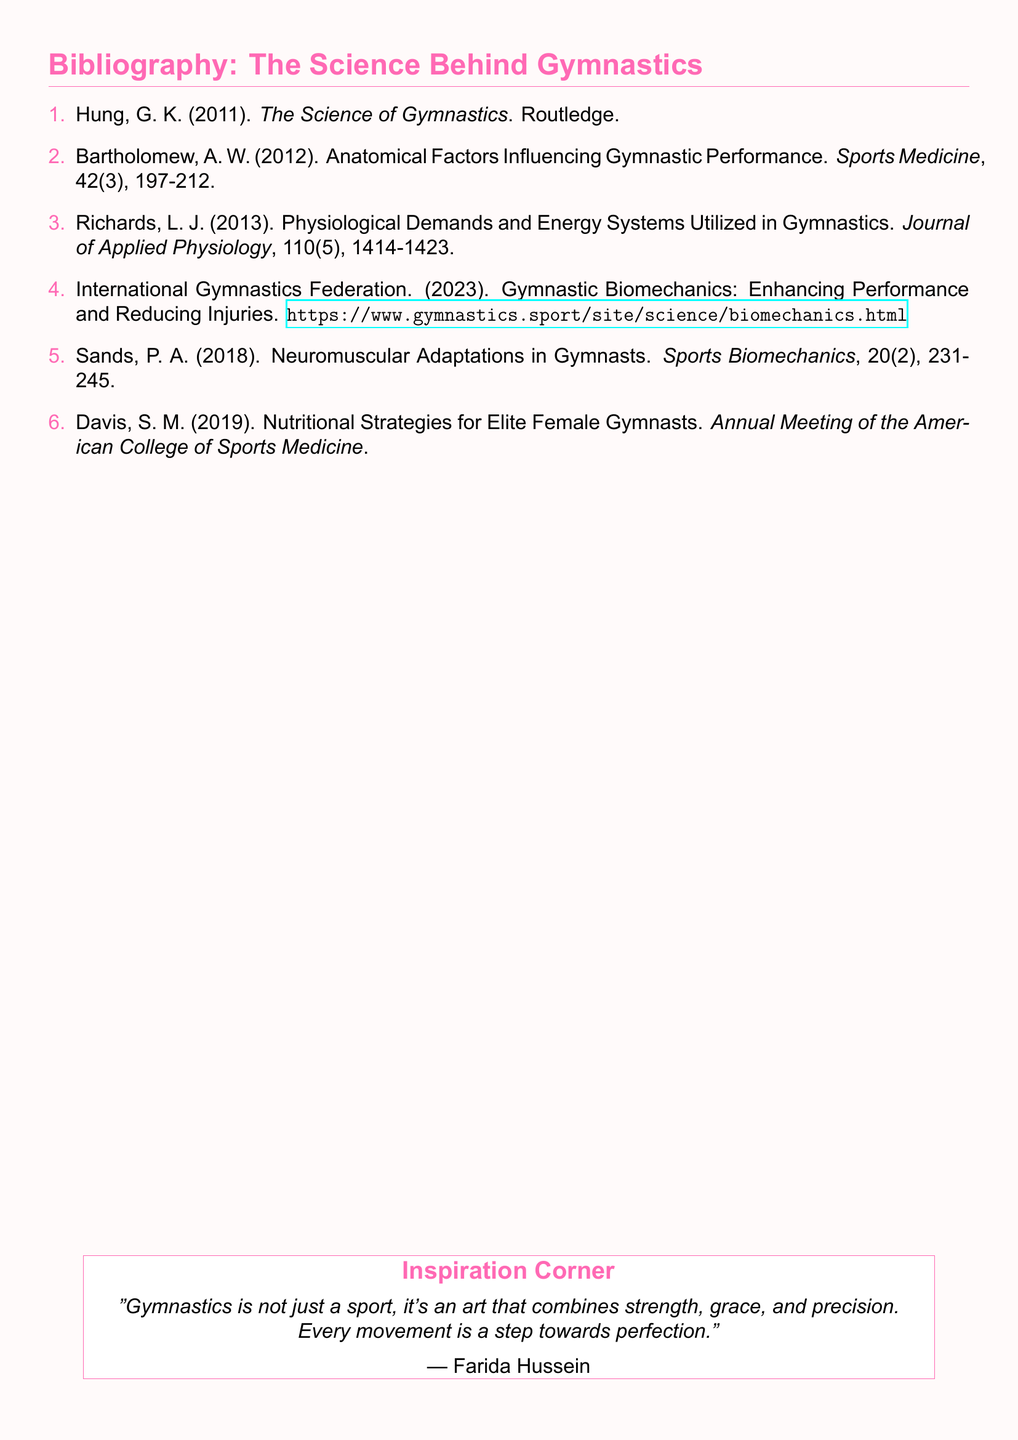what is the title of the first reference? The title of the first reference is found in the bibliography, and it is "The Science of Gymnastics".
Answer: The Science of Gymnastics who is the author of the reference discussing anatomical factors? The author is identified in the bibliography as discussing anatomical factors influencing performance, which is Bartholomew, A. W.
Answer: Bartholomew, A. W in what year was the article on neuromuscular adaptations published? The publication year for the reference on neuromuscular adaptations in gymnasts is stated in the bibliography, which is 2018.
Answer: 2018 how many references are listed in the bibliography? The total number of references is counted directly from the list and amounts to six.
Answer: 6 what is the source type of the 2023 reference? The 2023 reference is a webpage from the International Gymnastics Federation and is recognized as a source in the bibliography.
Answer: webpage what journal published the article on physiological demands? The article on physiological demands is published in the "Journal of Applied Physiology", as noted in the bibliography.
Answer: Journal of Applied Physiology who is quoted in the "Inspiration Corner"? The quote in the "Inspiration Corner" is attributed to Farida Hussein, who is also highlighted as an inspirational gymnastics figure.
Answer: Farida Hussein what specific strategies does the 2019 reference discuss? The 2019 reference by Davis, S. M. discusses nutritional strategies for elite female gymnasts, according to the bibliography.
Answer: nutritional strategies 